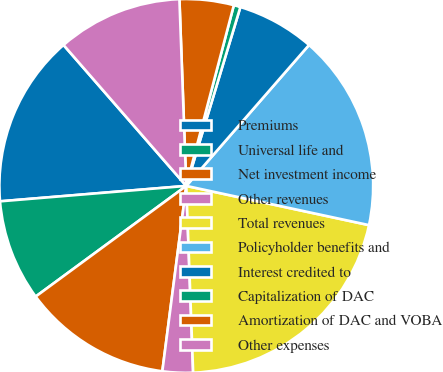Convert chart. <chart><loc_0><loc_0><loc_500><loc_500><pie_chart><fcel>Premiums<fcel>Universal life and<fcel>Net investment income<fcel>Other revenues<fcel>Total revenues<fcel>Policyholder benefits and<fcel>Interest credited to<fcel>Capitalization of DAC<fcel>Amortization of DAC and VOBA<fcel>Other expenses<nl><fcel>14.91%<fcel>8.77%<fcel>12.87%<fcel>2.63%<fcel>21.05%<fcel>16.96%<fcel>6.73%<fcel>0.58%<fcel>4.68%<fcel>10.82%<nl></chart> 